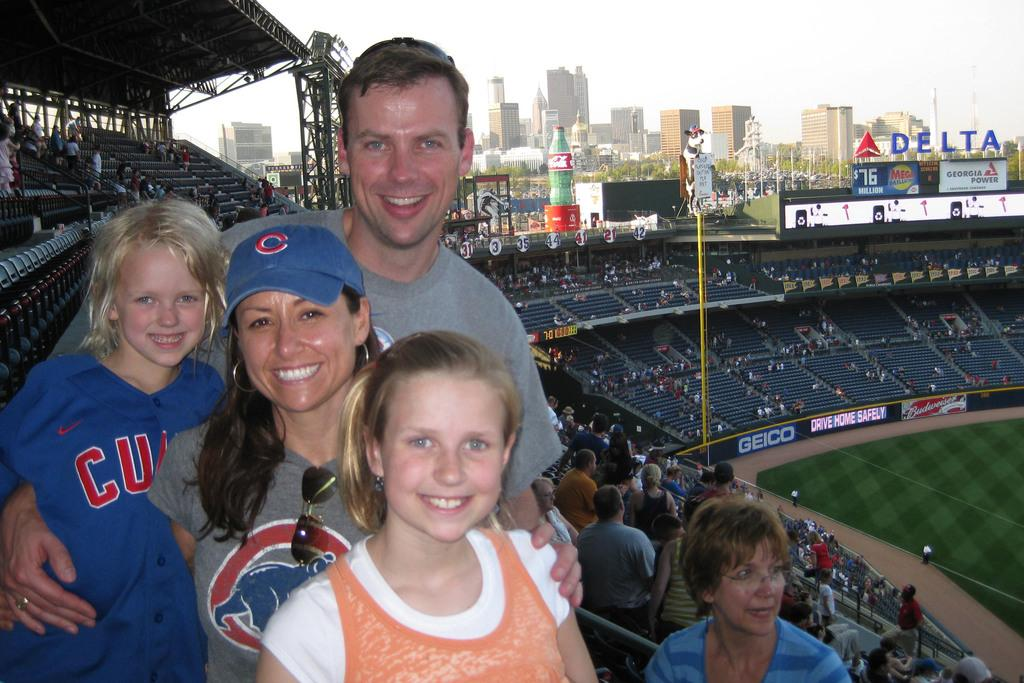<image>
Share a concise interpretation of the image provided. A family take a photo a thte baseball game at the Delta stadium which carries advertising for Geico and Gergia power amongst others. 